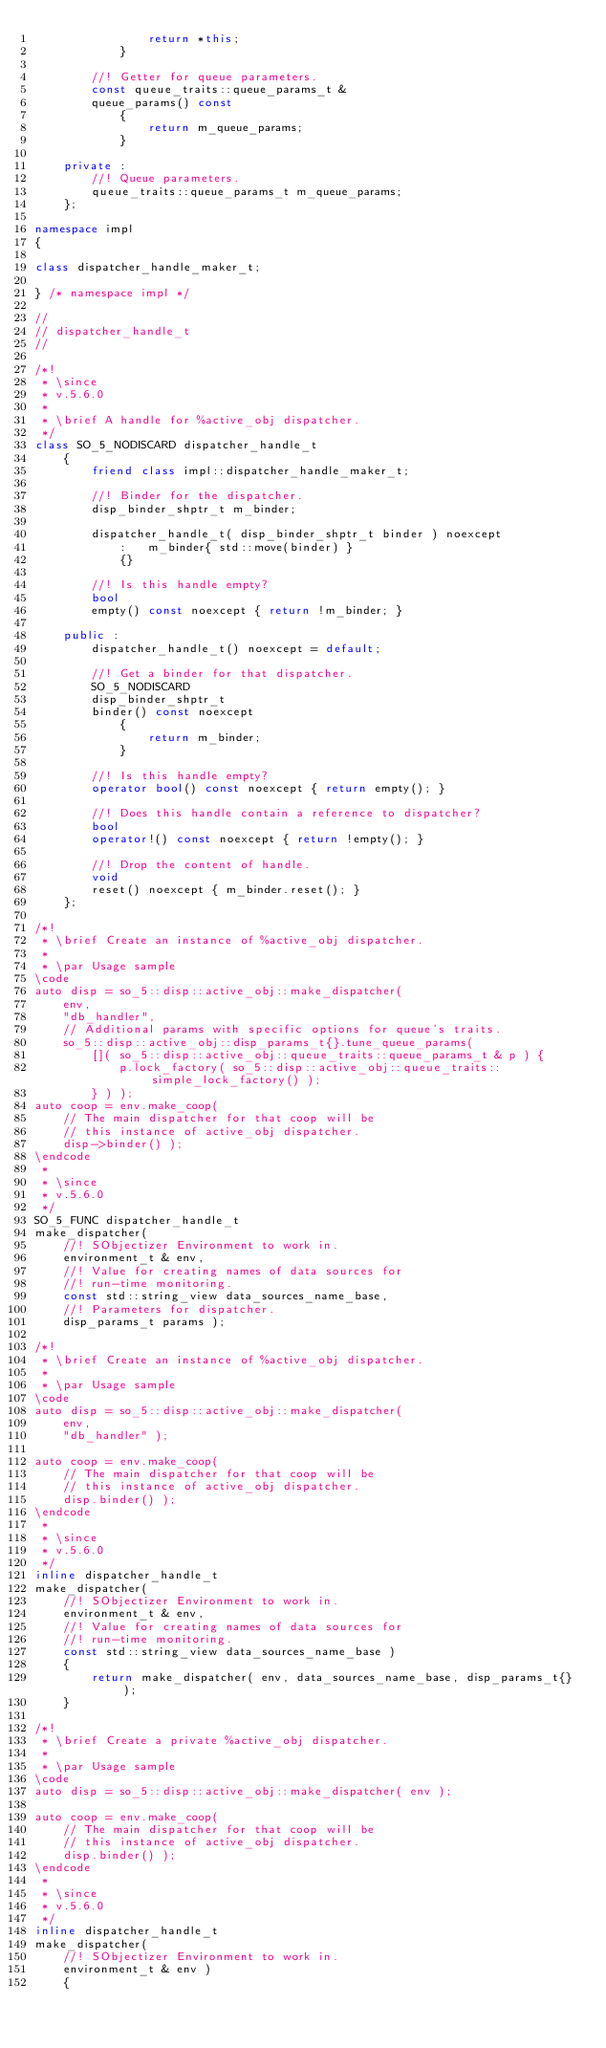Convert code to text. <code><loc_0><loc_0><loc_500><loc_500><_C++_>				return *this;
			}

		//! Getter for queue parameters.
		const queue_traits::queue_params_t &
		queue_params() const
			{
				return m_queue_params;
			}

	private :
		//! Queue parameters.
		queue_traits::queue_params_t m_queue_params;
	};

namespace impl
{

class dispatcher_handle_maker_t;

} /* namespace impl */

//
// dispatcher_handle_t
//

/*!
 * \since
 * v.5.6.0
 *
 * \brief A handle for %active_obj dispatcher.
 */
class SO_5_NODISCARD dispatcher_handle_t
	{
		friend class impl::dispatcher_handle_maker_t;

		//! Binder for the dispatcher.
		disp_binder_shptr_t m_binder;

		dispatcher_handle_t( disp_binder_shptr_t binder ) noexcept
			:	m_binder{ std::move(binder) }
			{}

		//! Is this handle empty?
		bool
		empty() const noexcept { return !m_binder; }

	public :
		dispatcher_handle_t() noexcept = default;

		//! Get a binder for that dispatcher.
		SO_5_NODISCARD
		disp_binder_shptr_t
		binder() const noexcept
			{
				return m_binder;
			}

		//! Is this handle empty?
		operator bool() const noexcept { return empty(); }

		//! Does this handle contain a reference to dispatcher?
		bool
		operator!() const noexcept { return !empty(); }

		//! Drop the content of handle.
		void
		reset() noexcept { m_binder.reset(); }
	};

/*!
 * \brief Create an instance of %active_obj dispatcher.
 *
 * \par Usage sample
\code
auto disp = so_5::disp::active_obj::make_dispatcher(
	env,
	"db_handler",
	// Additional params with specific options for queue's traits.
	so_5::disp::active_obj::disp_params_t{}.tune_queue_params(
		[]( so_5::disp::active_obj::queue_traits::queue_params_t & p ) {
			p.lock_factory( so_5::disp::active_obj::queue_traits::simple_lock_factory() );
		} ) );
auto coop = env.make_coop(
	// The main dispatcher for that coop will be
	// this instance of active_obj dispatcher.
	disp->binder() );
\endcode
 *
 * \since
 * v.5.6.0
 */
SO_5_FUNC dispatcher_handle_t
make_dispatcher(
	//! SObjectizer Environment to work in.
	environment_t & env,
	//! Value for creating names of data sources for
	//! run-time monitoring.
	const std::string_view data_sources_name_base,
	//! Parameters for dispatcher.
	disp_params_t params );

/*!
 * \brief Create an instance of %active_obj dispatcher.
 *
 * \par Usage sample
\code
auto disp = so_5::disp::active_obj::make_dispatcher(
	env,
	"db_handler" );

auto coop = env.make_coop(
	// The main dispatcher for that coop will be
	// this instance of active_obj dispatcher.
	disp.binder() );
\endcode
 *
 * \since
 * v.5.6.0
 */
inline dispatcher_handle_t
make_dispatcher(
	//! SObjectizer Environment to work in.
	environment_t & env,
	//! Value for creating names of data sources for
	//! run-time monitoring.
	const std::string_view data_sources_name_base )
	{
		return make_dispatcher( env, data_sources_name_base, disp_params_t{} );
	}

/*!
 * \brief Create a private %active_obj dispatcher.
 *
 * \par Usage sample
\code
auto disp = so_5::disp::active_obj::make_dispatcher( env );

auto coop = env.make_coop(
	// The main dispatcher for that coop will be
	// this instance of active_obj dispatcher.
	disp.binder() );
\endcode
 *
 * \since
 * v.5.6.0
 */
inline dispatcher_handle_t
make_dispatcher(
	//! SObjectizer Environment to work in.
	environment_t & env )
	{</code> 